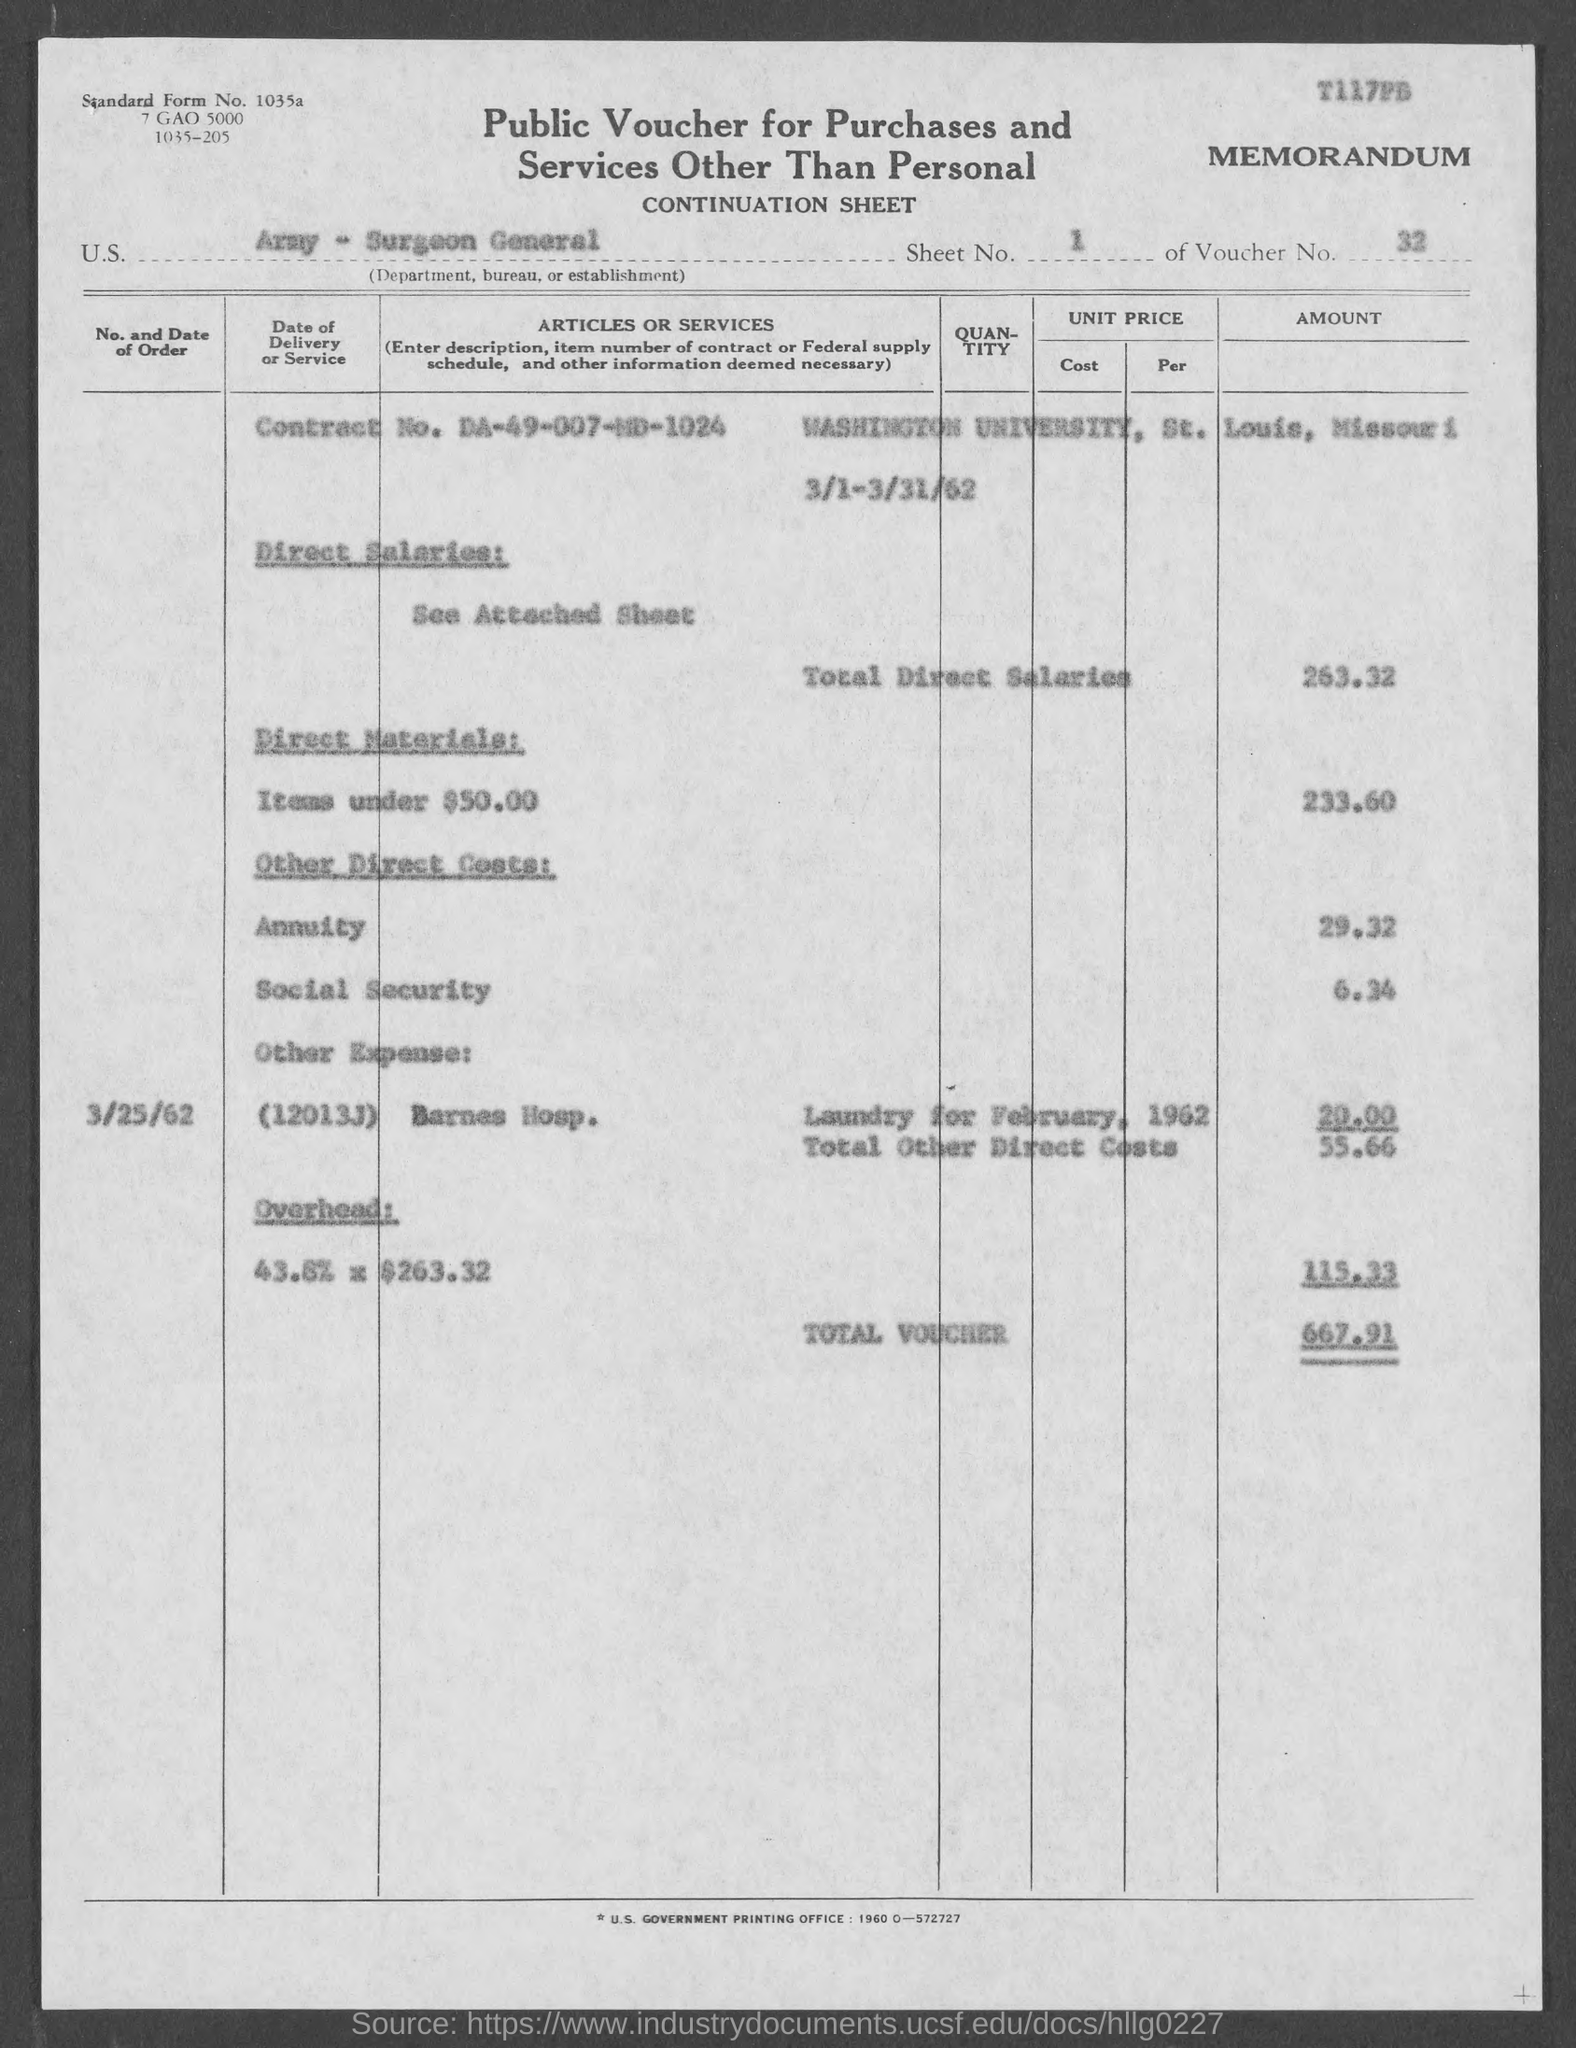What is the sheet number ?
Give a very brief answer. 1. What is the name of the university ?
Ensure brevity in your answer.  Washington University. How much is the total direct salaries ?
Offer a terse response. 263.32. How much is the total voucher ?
Offer a very short reply. 667.91. What is the cost of direct materials for items under $50.00 ?
Ensure brevity in your answer.  233.60. How much is the cost for social security ?
Make the answer very short. 6.34. What is the date of order for barnes hosp .
Provide a short and direct response. 3/25/62. What is the cost for annuity ?
Make the answer very short. 29.32. 